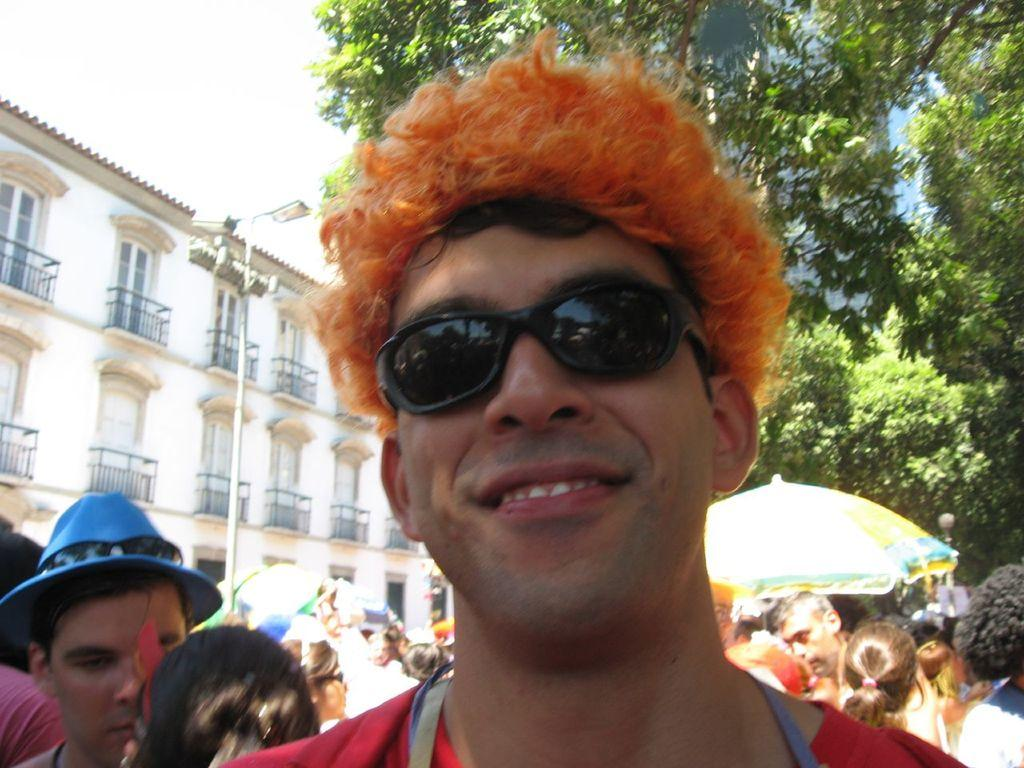Who or what can be seen in the image? There are people in the image. What can be seen in the distance behind the people? There are buildings, poles, trees, and the sky visible in the background of the image. What type of coast can be seen in the image? There is no coast visible in the image; it features people and various background elements. 